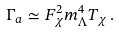<formula> <loc_0><loc_0><loc_500><loc_500>\Gamma _ { a } \simeq F _ { \chi } ^ { 2 } m _ { \Lambda } ^ { 4 } T _ { \chi } \, .</formula> 